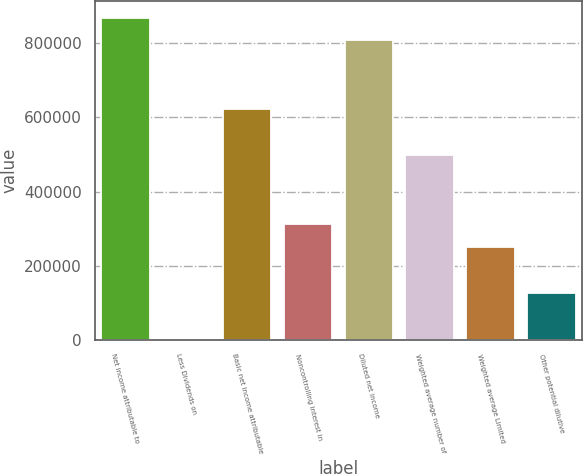Convert chart. <chart><loc_0><loc_0><loc_500><loc_500><bar_chart><fcel>Net income attributable to<fcel>Less Dividends on<fcel>Basic net income attributable<fcel>Noncontrolling interest in<fcel>Diluted net income<fcel>Weighted average number of<fcel>Weighted average Limited<fcel>Other potential dilutive<nl><fcel>869167<fcel>3081<fcel>621714<fcel>312398<fcel>807304<fcel>497987<fcel>250534<fcel>126808<nl></chart> 